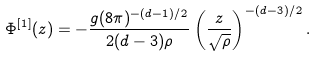<formula> <loc_0><loc_0><loc_500><loc_500>\Phi ^ { [ 1 ] } ( z ) = - \frac { g ( 8 \pi ) ^ { - ( d - 1 ) / 2 } } { 2 ( d - 3 ) \rho } \left ( \frac { z } { \sqrt { \rho } } \right ) ^ { - ( d - 3 ) / 2 } .</formula> 